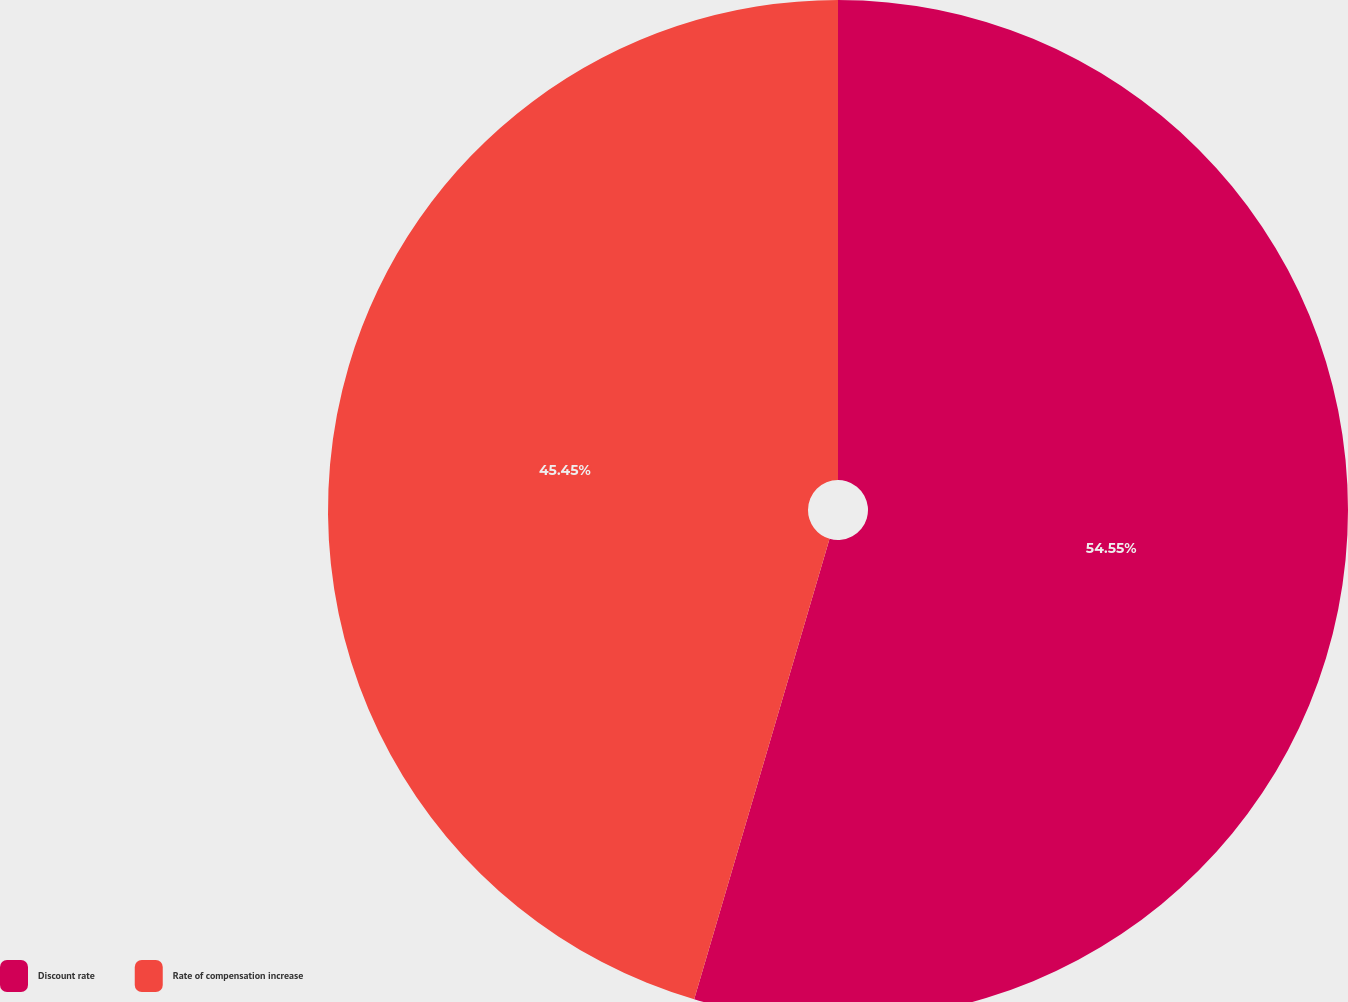<chart> <loc_0><loc_0><loc_500><loc_500><pie_chart><fcel>Discount rate<fcel>Rate of compensation increase<nl><fcel>54.55%<fcel>45.45%<nl></chart> 